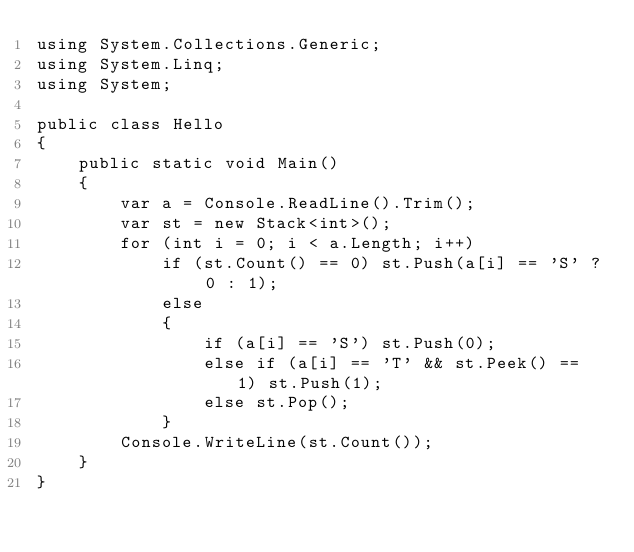Convert code to text. <code><loc_0><loc_0><loc_500><loc_500><_C#_>using System.Collections.Generic;
using System.Linq;
using System;

public class Hello
{
    public static void Main()
    {
        var a = Console.ReadLine().Trim();
        var st = new Stack<int>();
        for (int i = 0; i < a.Length; i++)
            if (st.Count() == 0) st.Push(a[i] == 'S' ? 0 : 1);
            else
            {
                if (a[i] == 'S') st.Push(0);
                else if (a[i] == 'T' && st.Peek() == 1) st.Push(1);
                else st.Pop();
            }
        Console.WriteLine(st.Count());
    }
}
</code> 